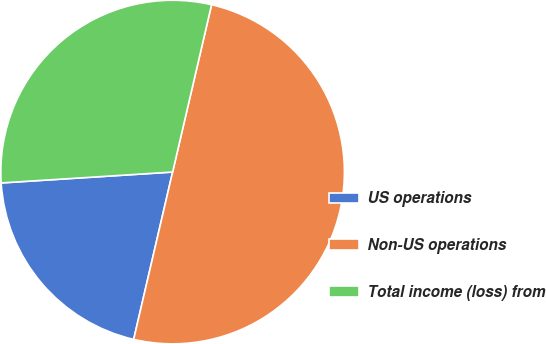Convert chart to OTSL. <chart><loc_0><loc_0><loc_500><loc_500><pie_chart><fcel>US operations<fcel>Non-US operations<fcel>Total income (loss) from<nl><fcel>20.35%<fcel>50.0%<fcel>29.65%<nl></chart> 